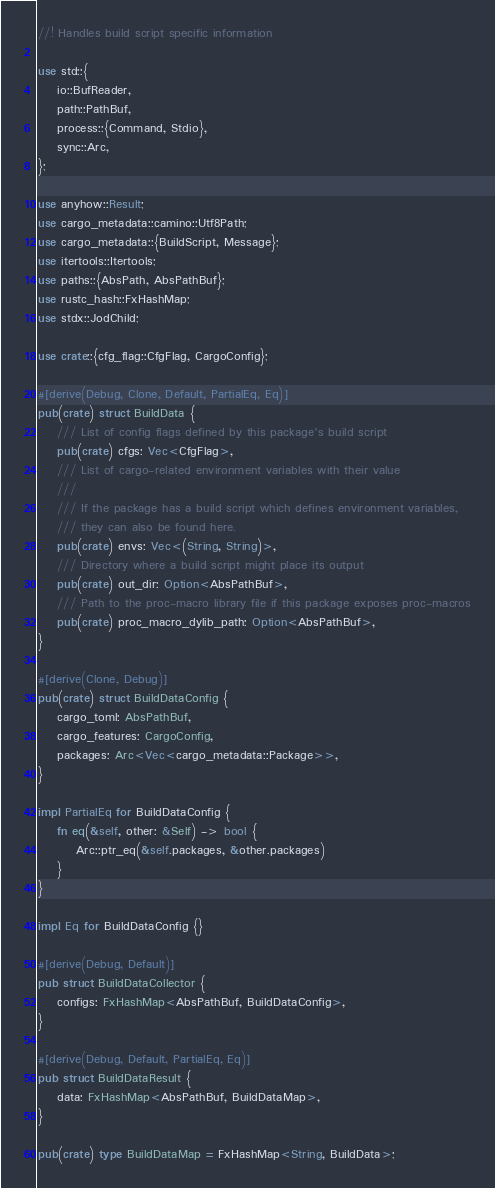Convert code to text. <code><loc_0><loc_0><loc_500><loc_500><_Rust_>//! Handles build script specific information

use std::{
    io::BufReader,
    path::PathBuf,
    process::{Command, Stdio},
    sync::Arc,
};

use anyhow::Result;
use cargo_metadata::camino::Utf8Path;
use cargo_metadata::{BuildScript, Message};
use itertools::Itertools;
use paths::{AbsPath, AbsPathBuf};
use rustc_hash::FxHashMap;
use stdx::JodChild;

use crate::{cfg_flag::CfgFlag, CargoConfig};

#[derive(Debug, Clone, Default, PartialEq, Eq)]
pub(crate) struct BuildData {
    /// List of config flags defined by this package's build script
    pub(crate) cfgs: Vec<CfgFlag>,
    /// List of cargo-related environment variables with their value
    ///
    /// If the package has a build script which defines environment variables,
    /// they can also be found here.
    pub(crate) envs: Vec<(String, String)>,
    /// Directory where a build script might place its output
    pub(crate) out_dir: Option<AbsPathBuf>,
    /// Path to the proc-macro library file if this package exposes proc-macros
    pub(crate) proc_macro_dylib_path: Option<AbsPathBuf>,
}

#[derive(Clone, Debug)]
pub(crate) struct BuildDataConfig {
    cargo_toml: AbsPathBuf,
    cargo_features: CargoConfig,
    packages: Arc<Vec<cargo_metadata::Package>>,
}

impl PartialEq for BuildDataConfig {
    fn eq(&self, other: &Self) -> bool {
        Arc::ptr_eq(&self.packages, &other.packages)
    }
}

impl Eq for BuildDataConfig {}

#[derive(Debug, Default)]
pub struct BuildDataCollector {
    configs: FxHashMap<AbsPathBuf, BuildDataConfig>,
}

#[derive(Debug, Default, PartialEq, Eq)]
pub struct BuildDataResult {
    data: FxHashMap<AbsPathBuf, BuildDataMap>,
}

pub(crate) type BuildDataMap = FxHashMap<String, BuildData>;
</code> 